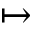<formula> <loc_0><loc_0><loc_500><loc_500>\mapsto</formula> 